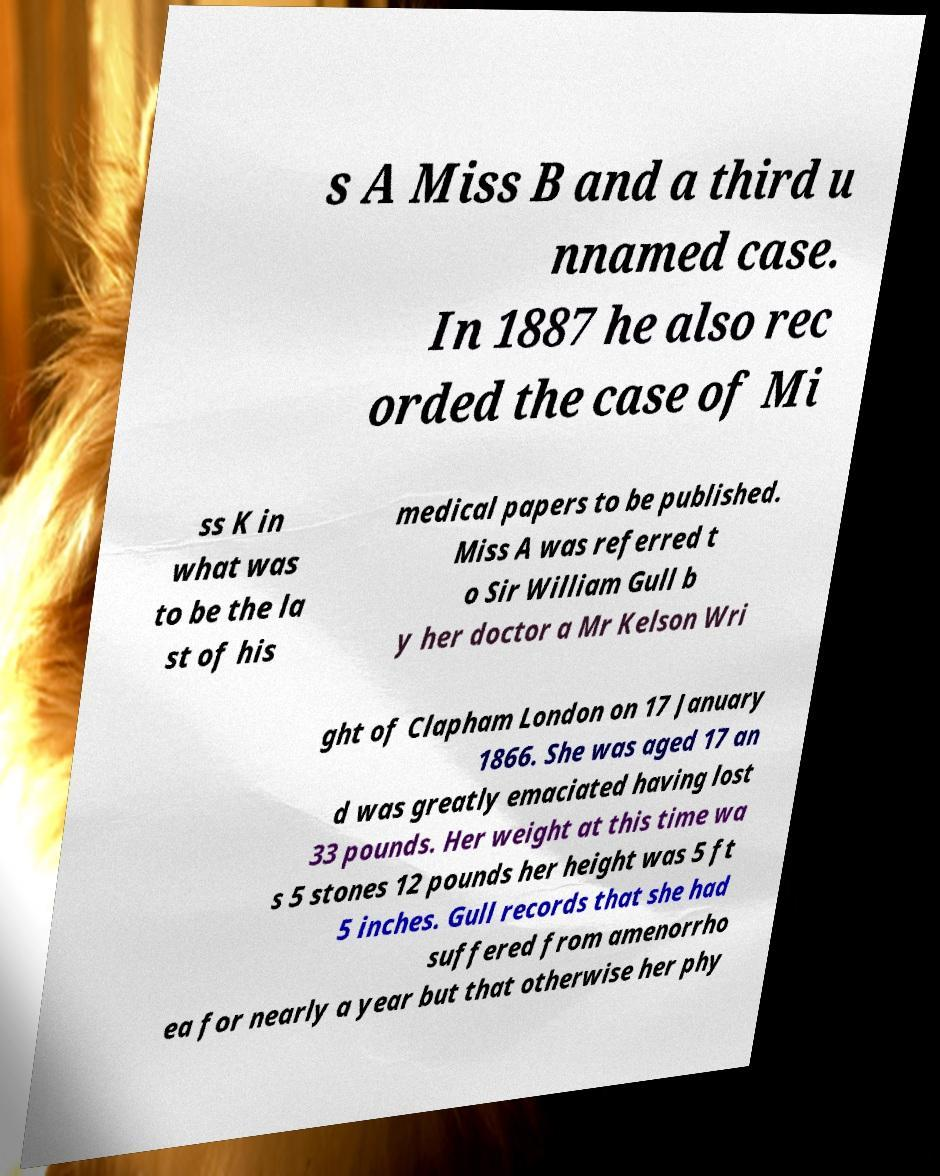Can you read and provide the text displayed in the image?This photo seems to have some interesting text. Can you extract and type it out for me? s A Miss B and a third u nnamed case. In 1887 he also rec orded the case of Mi ss K in what was to be the la st of his medical papers to be published. Miss A was referred t o Sir William Gull b y her doctor a Mr Kelson Wri ght of Clapham London on 17 January 1866. She was aged 17 an d was greatly emaciated having lost 33 pounds. Her weight at this time wa s 5 stones 12 pounds her height was 5 ft 5 inches. Gull records that she had suffered from amenorrho ea for nearly a year but that otherwise her phy 